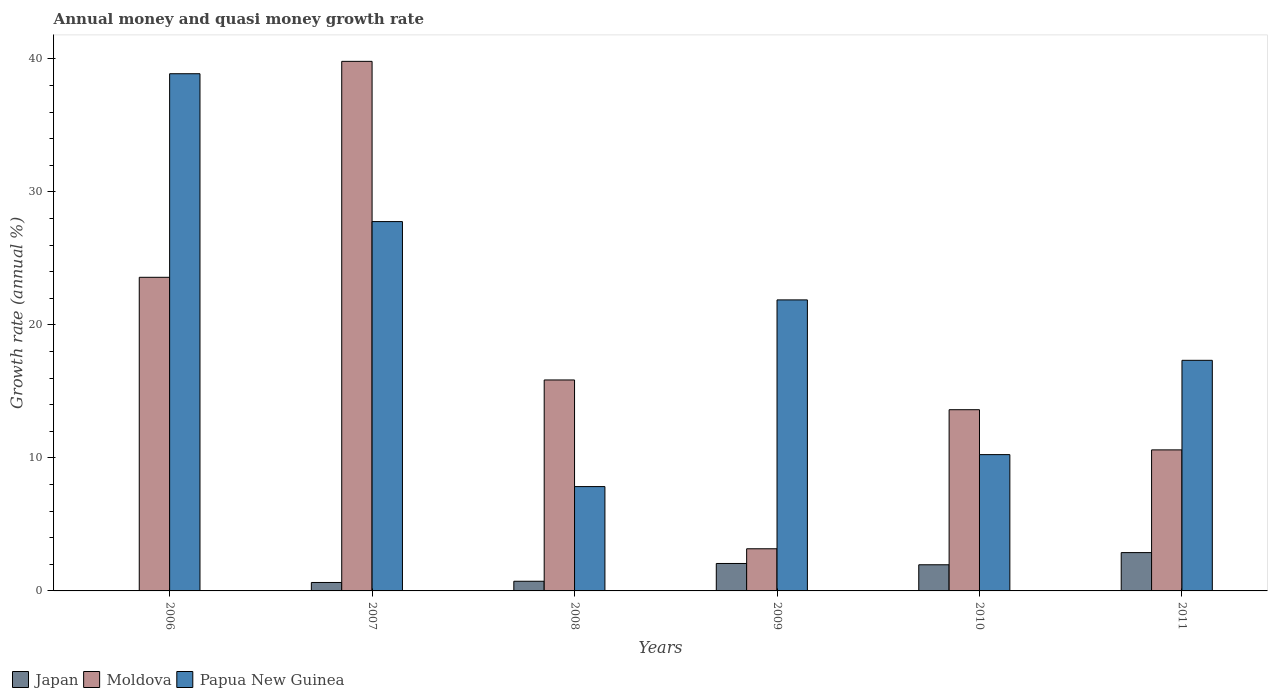How many different coloured bars are there?
Provide a short and direct response. 3. How many groups of bars are there?
Your response must be concise. 6. Are the number of bars per tick equal to the number of legend labels?
Give a very brief answer. No. How many bars are there on the 3rd tick from the right?
Give a very brief answer. 3. What is the growth rate in Moldova in 2011?
Provide a succinct answer. 10.6. Across all years, what is the maximum growth rate in Papua New Guinea?
Ensure brevity in your answer.  38.88. In which year was the growth rate in Moldova maximum?
Your answer should be very brief. 2007. What is the total growth rate in Moldova in the graph?
Offer a terse response. 106.64. What is the difference between the growth rate in Papua New Guinea in 2008 and that in 2010?
Your response must be concise. -2.4. What is the difference between the growth rate in Japan in 2010 and the growth rate in Moldova in 2009?
Your answer should be very brief. -1.2. What is the average growth rate in Moldova per year?
Provide a short and direct response. 17.77. In the year 2008, what is the difference between the growth rate in Japan and growth rate in Papua New Guinea?
Provide a succinct answer. -7.12. In how many years, is the growth rate in Papua New Guinea greater than 24 %?
Your answer should be compact. 2. What is the ratio of the growth rate in Japan in 2007 to that in 2008?
Your response must be concise. 0.87. Is the difference between the growth rate in Japan in 2010 and 2011 greater than the difference between the growth rate in Papua New Guinea in 2010 and 2011?
Your answer should be very brief. Yes. What is the difference between the highest and the second highest growth rate in Papua New Guinea?
Your response must be concise. 11.11. What is the difference between the highest and the lowest growth rate in Moldova?
Offer a terse response. 36.64. In how many years, is the growth rate in Japan greater than the average growth rate in Japan taken over all years?
Your response must be concise. 3. Is it the case that in every year, the sum of the growth rate in Japan and growth rate in Moldova is greater than the growth rate in Papua New Guinea?
Make the answer very short. No. How many bars are there?
Your response must be concise. 17. How many years are there in the graph?
Offer a very short reply. 6. What is the difference between two consecutive major ticks on the Y-axis?
Keep it short and to the point. 10. Are the values on the major ticks of Y-axis written in scientific E-notation?
Your answer should be compact. No. Does the graph contain grids?
Your answer should be very brief. No. How many legend labels are there?
Provide a short and direct response. 3. What is the title of the graph?
Your response must be concise. Annual money and quasi money growth rate. Does "Malawi" appear as one of the legend labels in the graph?
Make the answer very short. No. What is the label or title of the X-axis?
Ensure brevity in your answer.  Years. What is the label or title of the Y-axis?
Make the answer very short. Growth rate (annual %). What is the Growth rate (annual %) in Moldova in 2006?
Keep it short and to the point. 23.58. What is the Growth rate (annual %) in Papua New Guinea in 2006?
Your answer should be compact. 38.88. What is the Growth rate (annual %) of Japan in 2007?
Your answer should be compact. 0.63. What is the Growth rate (annual %) in Moldova in 2007?
Offer a very short reply. 39.81. What is the Growth rate (annual %) of Papua New Guinea in 2007?
Your response must be concise. 27.76. What is the Growth rate (annual %) of Japan in 2008?
Keep it short and to the point. 0.73. What is the Growth rate (annual %) in Moldova in 2008?
Ensure brevity in your answer.  15.86. What is the Growth rate (annual %) in Papua New Guinea in 2008?
Give a very brief answer. 7.84. What is the Growth rate (annual %) in Japan in 2009?
Offer a terse response. 2.06. What is the Growth rate (annual %) in Moldova in 2009?
Your answer should be compact. 3.17. What is the Growth rate (annual %) of Papua New Guinea in 2009?
Your answer should be very brief. 21.88. What is the Growth rate (annual %) in Japan in 2010?
Ensure brevity in your answer.  1.97. What is the Growth rate (annual %) of Moldova in 2010?
Your response must be concise. 13.62. What is the Growth rate (annual %) in Papua New Guinea in 2010?
Offer a terse response. 10.25. What is the Growth rate (annual %) of Japan in 2011?
Give a very brief answer. 2.88. What is the Growth rate (annual %) of Moldova in 2011?
Provide a succinct answer. 10.6. What is the Growth rate (annual %) of Papua New Guinea in 2011?
Keep it short and to the point. 17.34. Across all years, what is the maximum Growth rate (annual %) in Japan?
Your answer should be very brief. 2.88. Across all years, what is the maximum Growth rate (annual %) in Moldova?
Offer a very short reply. 39.81. Across all years, what is the maximum Growth rate (annual %) in Papua New Guinea?
Ensure brevity in your answer.  38.88. Across all years, what is the minimum Growth rate (annual %) in Japan?
Make the answer very short. 0. Across all years, what is the minimum Growth rate (annual %) in Moldova?
Provide a succinct answer. 3.17. Across all years, what is the minimum Growth rate (annual %) in Papua New Guinea?
Offer a very short reply. 7.84. What is the total Growth rate (annual %) in Japan in the graph?
Your answer should be compact. 8.27. What is the total Growth rate (annual %) of Moldova in the graph?
Your answer should be compact. 106.64. What is the total Growth rate (annual %) of Papua New Guinea in the graph?
Your answer should be compact. 123.95. What is the difference between the Growth rate (annual %) of Moldova in 2006 and that in 2007?
Your answer should be very brief. -16.23. What is the difference between the Growth rate (annual %) in Papua New Guinea in 2006 and that in 2007?
Ensure brevity in your answer.  11.11. What is the difference between the Growth rate (annual %) in Moldova in 2006 and that in 2008?
Your answer should be compact. 7.72. What is the difference between the Growth rate (annual %) of Papua New Guinea in 2006 and that in 2008?
Keep it short and to the point. 31.04. What is the difference between the Growth rate (annual %) of Moldova in 2006 and that in 2009?
Give a very brief answer. 20.41. What is the difference between the Growth rate (annual %) in Papua New Guinea in 2006 and that in 2009?
Offer a terse response. 17. What is the difference between the Growth rate (annual %) of Moldova in 2006 and that in 2010?
Ensure brevity in your answer.  9.95. What is the difference between the Growth rate (annual %) of Papua New Guinea in 2006 and that in 2010?
Your answer should be very brief. 28.63. What is the difference between the Growth rate (annual %) of Moldova in 2006 and that in 2011?
Your answer should be very brief. 12.97. What is the difference between the Growth rate (annual %) in Papua New Guinea in 2006 and that in 2011?
Your answer should be compact. 21.54. What is the difference between the Growth rate (annual %) of Japan in 2007 and that in 2008?
Keep it short and to the point. -0.09. What is the difference between the Growth rate (annual %) of Moldova in 2007 and that in 2008?
Make the answer very short. 23.95. What is the difference between the Growth rate (annual %) of Papua New Guinea in 2007 and that in 2008?
Give a very brief answer. 19.92. What is the difference between the Growth rate (annual %) of Japan in 2007 and that in 2009?
Give a very brief answer. -1.43. What is the difference between the Growth rate (annual %) in Moldova in 2007 and that in 2009?
Make the answer very short. 36.64. What is the difference between the Growth rate (annual %) in Papua New Guinea in 2007 and that in 2009?
Make the answer very short. 5.89. What is the difference between the Growth rate (annual %) in Japan in 2007 and that in 2010?
Keep it short and to the point. -1.33. What is the difference between the Growth rate (annual %) in Moldova in 2007 and that in 2010?
Provide a short and direct response. 26.19. What is the difference between the Growth rate (annual %) of Papua New Guinea in 2007 and that in 2010?
Your answer should be compact. 17.52. What is the difference between the Growth rate (annual %) of Japan in 2007 and that in 2011?
Your answer should be very brief. -2.25. What is the difference between the Growth rate (annual %) of Moldova in 2007 and that in 2011?
Your answer should be compact. 29.21. What is the difference between the Growth rate (annual %) in Papua New Guinea in 2007 and that in 2011?
Offer a very short reply. 10.43. What is the difference between the Growth rate (annual %) in Japan in 2008 and that in 2009?
Your response must be concise. -1.34. What is the difference between the Growth rate (annual %) of Moldova in 2008 and that in 2009?
Your answer should be very brief. 12.69. What is the difference between the Growth rate (annual %) of Papua New Guinea in 2008 and that in 2009?
Offer a very short reply. -14.03. What is the difference between the Growth rate (annual %) in Japan in 2008 and that in 2010?
Provide a short and direct response. -1.24. What is the difference between the Growth rate (annual %) in Moldova in 2008 and that in 2010?
Keep it short and to the point. 2.24. What is the difference between the Growth rate (annual %) in Papua New Guinea in 2008 and that in 2010?
Keep it short and to the point. -2.4. What is the difference between the Growth rate (annual %) in Japan in 2008 and that in 2011?
Keep it short and to the point. -2.15. What is the difference between the Growth rate (annual %) in Moldova in 2008 and that in 2011?
Your answer should be very brief. 5.26. What is the difference between the Growth rate (annual %) in Papua New Guinea in 2008 and that in 2011?
Offer a terse response. -9.49. What is the difference between the Growth rate (annual %) of Japan in 2009 and that in 2010?
Make the answer very short. 0.1. What is the difference between the Growth rate (annual %) in Moldova in 2009 and that in 2010?
Provide a short and direct response. -10.45. What is the difference between the Growth rate (annual %) of Papua New Guinea in 2009 and that in 2010?
Your answer should be very brief. 11.63. What is the difference between the Growth rate (annual %) of Japan in 2009 and that in 2011?
Offer a very short reply. -0.82. What is the difference between the Growth rate (annual %) in Moldova in 2009 and that in 2011?
Your answer should be very brief. -7.43. What is the difference between the Growth rate (annual %) of Papua New Guinea in 2009 and that in 2011?
Provide a short and direct response. 4.54. What is the difference between the Growth rate (annual %) in Japan in 2010 and that in 2011?
Offer a very short reply. -0.92. What is the difference between the Growth rate (annual %) of Moldova in 2010 and that in 2011?
Your response must be concise. 3.02. What is the difference between the Growth rate (annual %) in Papua New Guinea in 2010 and that in 2011?
Your answer should be compact. -7.09. What is the difference between the Growth rate (annual %) of Moldova in 2006 and the Growth rate (annual %) of Papua New Guinea in 2007?
Your response must be concise. -4.19. What is the difference between the Growth rate (annual %) of Moldova in 2006 and the Growth rate (annual %) of Papua New Guinea in 2008?
Offer a very short reply. 15.73. What is the difference between the Growth rate (annual %) in Moldova in 2006 and the Growth rate (annual %) in Papua New Guinea in 2009?
Keep it short and to the point. 1.7. What is the difference between the Growth rate (annual %) of Moldova in 2006 and the Growth rate (annual %) of Papua New Guinea in 2010?
Your response must be concise. 13.33. What is the difference between the Growth rate (annual %) of Moldova in 2006 and the Growth rate (annual %) of Papua New Guinea in 2011?
Give a very brief answer. 6.24. What is the difference between the Growth rate (annual %) in Japan in 2007 and the Growth rate (annual %) in Moldova in 2008?
Give a very brief answer. -15.22. What is the difference between the Growth rate (annual %) of Japan in 2007 and the Growth rate (annual %) of Papua New Guinea in 2008?
Provide a short and direct response. -7.21. What is the difference between the Growth rate (annual %) in Moldova in 2007 and the Growth rate (annual %) in Papua New Guinea in 2008?
Your answer should be compact. 31.97. What is the difference between the Growth rate (annual %) in Japan in 2007 and the Growth rate (annual %) in Moldova in 2009?
Offer a terse response. -2.53. What is the difference between the Growth rate (annual %) in Japan in 2007 and the Growth rate (annual %) in Papua New Guinea in 2009?
Provide a succinct answer. -21.24. What is the difference between the Growth rate (annual %) of Moldova in 2007 and the Growth rate (annual %) of Papua New Guinea in 2009?
Your response must be concise. 17.93. What is the difference between the Growth rate (annual %) in Japan in 2007 and the Growth rate (annual %) in Moldova in 2010?
Make the answer very short. -12.99. What is the difference between the Growth rate (annual %) in Japan in 2007 and the Growth rate (annual %) in Papua New Guinea in 2010?
Your answer should be very brief. -9.61. What is the difference between the Growth rate (annual %) of Moldova in 2007 and the Growth rate (annual %) of Papua New Guinea in 2010?
Provide a succinct answer. 29.56. What is the difference between the Growth rate (annual %) of Japan in 2007 and the Growth rate (annual %) of Moldova in 2011?
Give a very brief answer. -9.97. What is the difference between the Growth rate (annual %) in Japan in 2007 and the Growth rate (annual %) in Papua New Guinea in 2011?
Your response must be concise. -16.7. What is the difference between the Growth rate (annual %) in Moldova in 2007 and the Growth rate (annual %) in Papua New Guinea in 2011?
Your answer should be very brief. 22.48. What is the difference between the Growth rate (annual %) in Japan in 2008 and the Growth rate (annual %) in Moldova in 2009?
Make the answer very short. -2.44. What is the difference between the Growth rate (annual %) of Japan in 2008 and the Growth rate (annual %) of Papua New Guinea in 2009?
Your answer should be very brief. -21.15. What is the difference between the Growth rate (annual %) in Moldova in 2008 and the Growth rate (annual %) in Papua New Guinea in 2009?
Offer a terse response. -6.02. What is the difference between the Growth rate (annual %) of Japan in 2008 and the Growth rate (annual %) of Moldova in 2010?
Ensure brevity in your answer.  -12.9. What is the difference between the Growth rate (annual %) in Japan in 2008 and the Growth rate (annual %) in Papua New Guinea in 2010?
Your response must be concise. -9.52. What is the difference between the Growth rate (annual %) in Moldova in 2008 and the Growth rate (annual %) in Papua New Guinea in 2010?
Make the answer very short. 5.61. What is the difference between the Growth rate (annual %) of Japan in 2008 and the Growth rate (annual %) of Moldova in 2011?
Provide a short and direct response. -9.88. What is the difference between the Growth rate (annual %) of Japan in 2008 and the Growth rate (annual %) of Papua New Guinea in 2011?
Your response must be concise. -16.61. What is the difference between the Growth rate (annual %) of Moldova in 2008 and the Growth rate (annual %) of Papua New Guinea in 2011?
Give a very brief answer. -1.48. What is the difference between the Growth rate (annual %) in Japan in 2009 and the Growth rate (annual %) in Moldova in 2010?
Give a very brief answer. -11.56. What is the difference between the Growth rate (annual %) in Japan in 2009 and the Growth rate (annual %) in Papua New Guinea in 2010?
Make the answer very short. -8.18. What is the difference between the Growth rate (annual %) of Moldova in 2009 and the Growth rate (annual %) of Papua New Guinea in 2010?
Offer a terse response. -7.08. What is the difference between the Growth rate (annual %) of Japan in 2009 and the Growth rate (annual %) of Moldova in 2011?
Offer a very short reply. -8.54. What is the difference between the Growth rate (annual %) in Japan in 2009 and the Growth rate (annual %) in Papua New Guinea in 2011?
Make the answer very short. -15.27. What is the difference between the Growth rate (annual %) in Moldova in 2009 and the Growth rate (annual %) in Papua New Guinea in 2011?
Your answer should be very brief. -14.17. What is the difference between the Growth rate (annual %) of Japan in 2010 and the Growth rate (annual %) of Moldova in 2011?
Offer a very short reply. -8.64. What is the difference between the Growth rate (annual %) of Japan in 2010 and the Growth rate (annual %) of Papua New Guinea in 2011?
Ensure brevity in your answer.  -15.37. What is the difference between the Growth rate (annual %) in Moldova in 2010 and the Growth rate (annual %) in Papua New Guinea in 2011?
Offer a very short reply. -3.71. What is the average Growth rate (annual %) in Japan per year?
Your answer should be compact. 1.38. What is the average Growth rate (annual %) in Moldova per year?
Your answer should be very brief. 17.77. What is the average Growth rate (annual %) in Papua New Guinea per year?
Your answer should be compact. 20.66. In the year 2006, what is the difference between the Growth rate (annual %) in Moldova and Growth rate (annual %) in Papua New Guinea?
Your answer should be compact. -15.3. In the year 2007, what is the difference between the Growth rate (annual %) in Japan and Growth rate (annual %) in Moldova?
Keep it short and to the point. -39.18. In the year 2007, what is the difference between the Growth rate (annual %) of Japan and Growth rate (annual %) of Papua New Guinea?
Your answer should be compact. -27.13. In the year 2007, what is the difference between the Growth rate (annual %) of Moldova and Growth rate (annual %) of Papua New Guinea?
Your answer should be very brief. 12.05. In the year 2008, what is the difference between the Growth rate (annual %) of Japan and Growth rate (annual %) of Moldova?
Offer a terse response. -15.13. In the year 2008, what is the difference between the Growth rate (annual %) in Japan and Growth rate (annual %) in Papua New Guinea?
Your response must be concise. -7.12. In the year 2008, what is the difference between the Growth rate (annual %) in Moldova and Growth rate (annual %) in Papua New Guinea?
Provide a succinct answer. 8.02. In the year 2009, what is the difference between the Growth rate (annual %) in Japan and Growth rate (annual %) in Moldova?
Provide a succinct answer. -1.1. In the year 2009, what is the difference between the Growth rate (annual %) of Japan and Growth rate (annual %) of Papua New Guinea?
Your answer should be very brief. -19.81. In the year 2009, what is the difference between the Growth rate (annual %) of Moldova and Growth rate (annual %) of Papua New Guinea?
Ensure brevity in your answer.  -18.71. In the year 2010, what is the difference between the Growth rate (annual %) of Japan and Growth rate (annual %) of Moldova?
Your response must be concise. -11.66. In the year 2010, what is the difference between the Growth rate (annual %) in Japan and Growth rate (annual %) in Papua New Guinea?
Your answer should be compact. -8.28. In the year 2010, what is the difference between the Growth rate (annual %) in Moldova and Growth rate (annual %) in Papua New Guinea?
Your answer should be compact. 3.38. In the year 2011, what is the difference between the Growth rate (annual %) in Japan and Growth rate (annual %) in Moldova?
Offer a terse response. -7.72. In the year 2011, what is the difference between the Growth rate (annual %) in Japan and Growth rate (annual %) in Papua New Guinea?
Your answer should be very brief. -14.45. In the year 2011, what is the difference between the Growth rate (annual %) in Moldova and Growth rate (annual %) in Papua New Guinea?
Offer a very short reply. -6.73. What is the ratio of the Growth rate (annual %) in Moldova in 2006 to that in 2007?
Ensure brevity in your answer.  0.59. What is the ratio of the Growth rate (annual %) in Papua New Guinea in 2006 to that in 2007?
Your answer should be very brief. 1.4. What is the ratio of the Growth rate (annual %) of Moldova in 2006 to that in 2008?
Provide a succinct answer. 1.49. What is the ratio of the Growth rate (annual %) in Papua New Guinea in 2006 to that in 2008?
Your answer should be very brief. 4.96. What is the ratio of the Growth rate (annual %) in Moldova in 2006 to that in 2009?
Give a very brief answer. 7.44. What is the ratio of the Growth rate (annual %) of Papua New Guinea in 2006 to that in 2009?
Your answer should be compact. 1.78. What is the ratio of the Growth rate (annual %) in Moldova in 2006 to that in 2010?
Offer a terse response. 1.73. What is the ratio of the Growth rate (annual %) in Papua New Guinea in 2006 to that in 2010?
Make the answer very short. 3.79. What is the ratio of the Growth rate (annual %) of Moldova in 2006 to that in 2011?
Make the answer very short. 2.22. What is the ratio of the Growth rate (annual %) in Papua New Guinea in 2006 to that in 2011?
Keep it short and to the point. 2.24. What is the ratio of the Growth rate (annual %) in Japan in 2007 to that in 2008?
Your answer should be very brief. 0.87. What is the ratio of the Growth rate (annual %) of Moldova in 2007 to that in 2008?
Offer a very short reply. 2.51. What is the ratio of the Growth rate (annual %) of Papua New Guinea in 2007 to that in 2008?
Your response must be concise. 3.54. What is the ratio of the Growth rate (annual %) of Japan in 2007 to that in 2009?
Your answer should be very brief. 0.31. What is the ratio of the Growth rate (annual %) in Moldova in 2007 to that in 2009?
Ensure brevity in your answer.  12.57. What is the ratio of the Growth rate (annual %) of Papua New Guinea in 2007 to that in 2009?
Give a very brief answer. 1.27. What is the ratio of the Growth rate (annual %) in Japan in 2007 to that in 2010?
Keep it short and to the point. 0.32. What is the ratio of the Growth rate (annual %) of Moldova in 2007 to that in 2010?
Provide a succinct answer. 2.92. What is the ratio of the Growth rate (annual %) of Papua New Guinea in 2007 to that in 2010?
Your answer should be very brief. 2.71. What is the ratio of the Growth rate (annual %) of Japan in 2007 to that in 2011?
Your answer should be very brief. 0.22. What is the ratio of the Growth rate (annual %) of Moldova in 2007 to that in 2011?
Your answer should be very brief. 3.75. What is the ratio of the Growth rate (annual %) in Papua New Guinea in 2007 to that in 2011?
Your answer should be compact. 1.6. What is the ratio of the Growth rate (annual %) in Japan in 2008 to that in 2009?
Your answer should be compact. 0.35. What is the ratio of the Growth rate (annual %) of Moldova in 2008 to that in 2009?
Make the answer very short. 5.01. What is the ratio of the Growth rate (annual %) of Papua New Guinea in 2008 to that in 2009?
Your response must be concise. 0.36. What is the ratio of the Growth rate (annual %) of Japan in 2008 to that in 2010?
Keep it short and to the point. 0.37. What is the ratio of the Growth rate (annual %) of Moldova in 2008 to that in 2010?
Offer a very short reply. 1.16. What is the ratio of the Growth rate (annual %) of Papua New Guinea in 2008 to that in 2010?
Offer a terse response. 0.77. What is the ratio of the Growth rate (annual %) in Japan in 2008 to that in 2011?
Ensure brevity in your answer.  0.25. What is the ratio of the Growth rate (annual %) of Moldova in 2008 to that in 2011?
Your answer should be compact. 1.5. What is the ratio of the Growth rate (annual %) in Papua New Guinea in 2008 to that in 2011?
Keep it short and to the point. 0.45. What is the ratio of the Growth rate (annual %) in Japan in 2009 to that in 2010?
Your response must be concise. 1.05. What is the ratio of the Growth rate (annual %) in Moldova in 2009 to that in 2010?
Keep it short and to the point. 0.23. What is the ratio of the Growth rate (annual %) of Papua New Guinea in 2009 to that in 2010?
Make the answer very short. 2.14. What is the ratio of the Growth rate (annual %) in Japan in 2009 to that in 2011?
Give a very brief answer. 0.72. What is the ratio of the Growth rate (annual %) of Moldova in 2009 to that in 2011?
Keep it short and to the point. 0.3. What is the ratio of the Growth rate (annual %) of Papua New Guinea in 2009 to that in 2011?
Your answer should be very brief. 1.26. What is the ratio of the Growth rate (annual %) of Japan in 2010 to that in 2011?
Ensure brevity in your answer.  0.68. What is the ratio of the Growth rate (annual %) of Moldova in 2010 to that in 2011?
Offer a very short reply. 1.28. What is the ratio of the Growth rate (annual %) of Papua New Guinea in 2010 to that in 2011?
Your answer should be very brief. 0.59. What is the difference between the highest and the second highest Growth rate (annual %) in Japan?
Offer a very short reply. 0.82. What is the difference between the highest and the second highest Growth rate (annual %) in Moldova?
Ensure brevity in your answer.  16.23. What is the difference between the highest and the second highest Growth rate (annual %) in Papua New Guinea?
Offer a very short reply. 11.11. What is the difference between the highest and the lowest Growth rate (annual %) in Japan?
Offer a very short reply. 2.88. What is the difference between the highest and the lowest Growth rate (annual %) of Moldova?
Offer a very short reply. 36.64. What is the difference between the highest and the lowest Growth rate (annual %) of Papua New Guinea?
Provide a short and direct response. 31.04. 